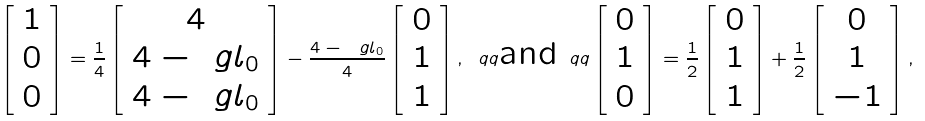Convert formula to latex. <formula><loc_0><loc_0><loc_500><loc_500>\left [ \begin{array} { c c c } 1 \\ 0 \\ 0 \end{array} \right ] = \frac { 1 } { 4 } \left [ \begin{array} { c c c } 4 \\ 4 - \ g l _ { 0 } \\ 4 - \ g l _ { 0 } \end{array} \right ] - \frac { 4 - \ g l _ { 0 } } { 4 } \left [ \begin{array} { c c c } 0 \\ 1 \\ 1 \end{array} \right ] , \ q q \text {and} \ q q \left [ \begin{array} { c c c } 0 \\ 1 \\ 0 \end{array} \right ] = \frac { 1 } { 2 } \left [ \begin{array} { c c c } 0 \\ 1 \\ 1 \end{array} \right ] + \frac { 1 } { 2 } \left [ \begin{array} { c c c } 0 \\ 1 \\ - 1 \end{array} \right ] ,</formula> 